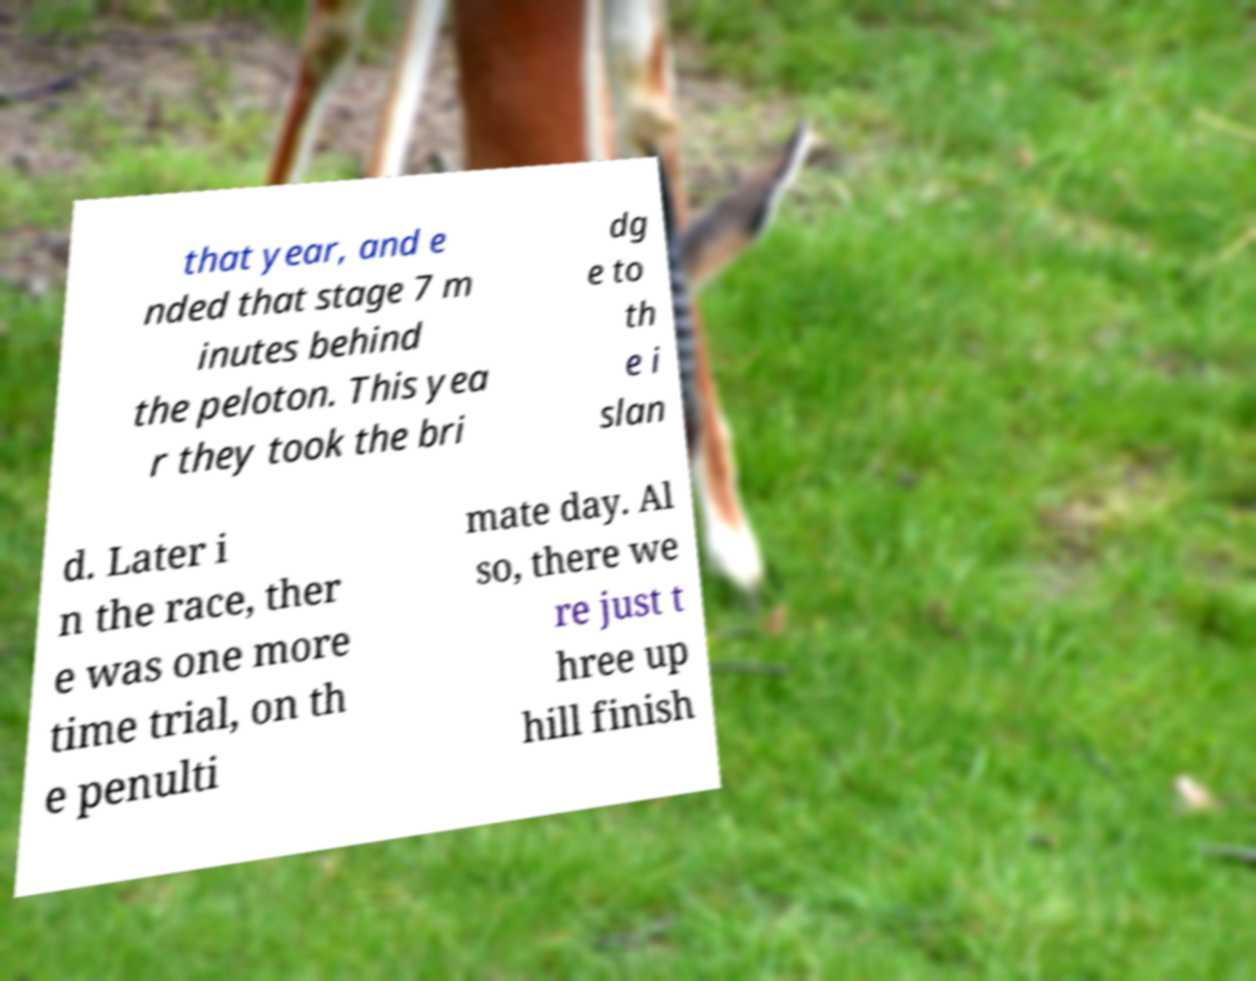Can you read and provide the text displayed in the image?This photo seems to have some interesting text. Can you extract and type it out for me? that year, and e nded that stage 7 m inutes behind the peloton. This yea r they took the bri dg e to th e i slan d. Later i n the race, ther e was one more time trial, on th e penulti mate day. Al so, there we re just t hree up hill finish 